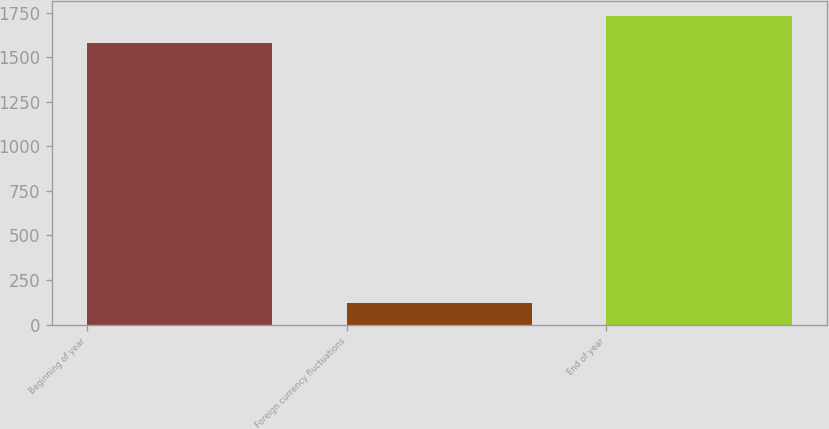Convert chart to OTSL. <chart><loc_0><loc_0><loc_500><loc_500><bar_chart><fcel>Beginning of year<fcel>Foreign currency fluctuations<fcel>End of year<nl><fcel>1581.1<fcel>120.1<fcel>1727.86<nl></chart> 